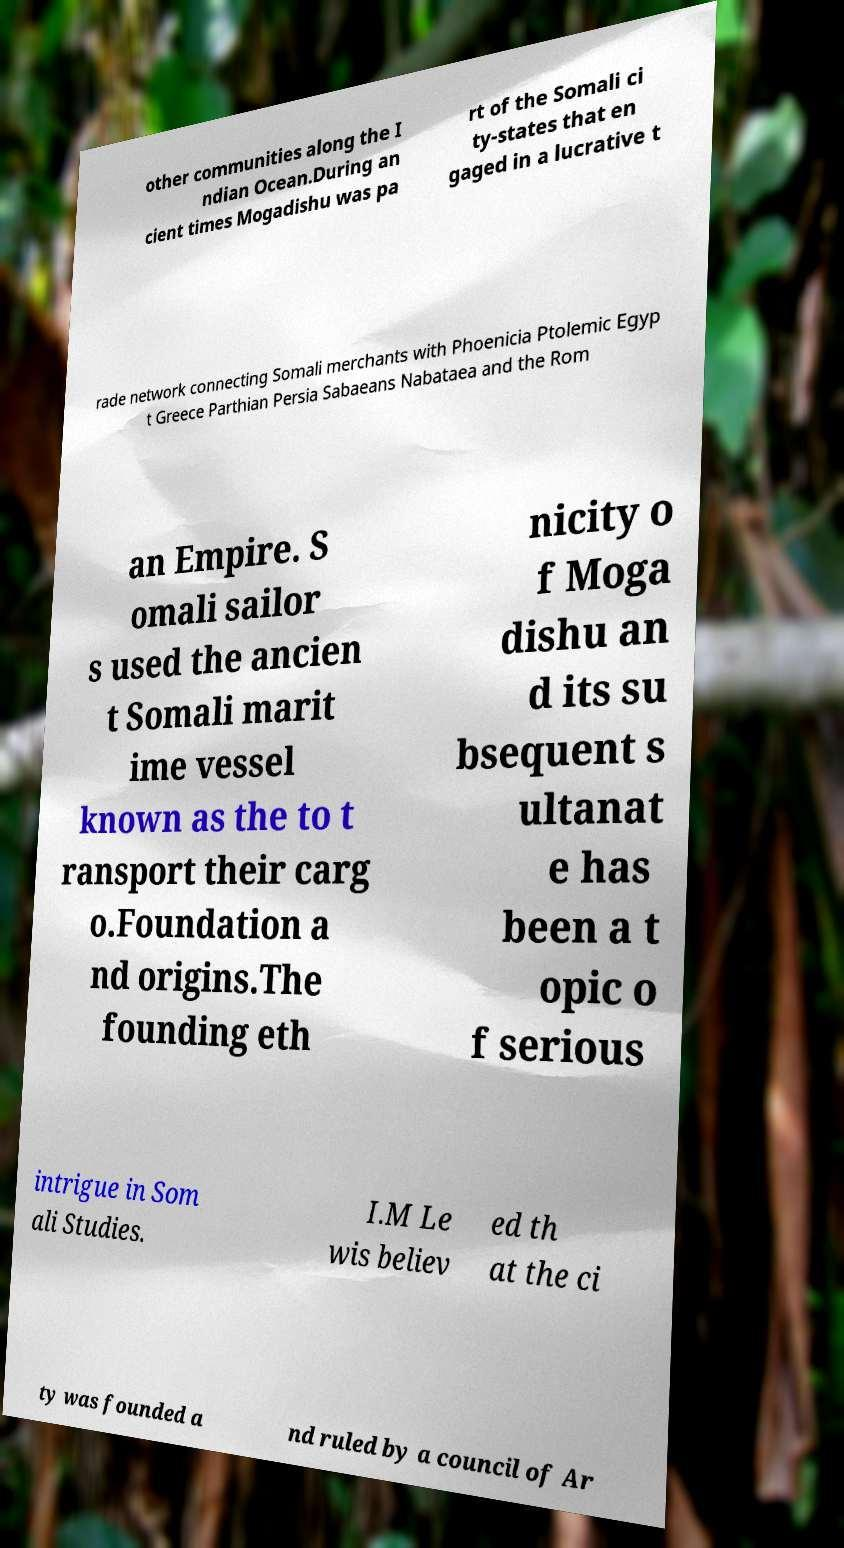Can you accurately transcribe the text from the provided image for me? other communities along the I ndian Ocean.During an cient times Mogadishu was pa rt of the Somali ci ty-states that en gaged in a lucrative t rade network connecting Somali merchants with Phoenicia Ptolemic Egyp t Greece Parthian Persia Sabaeans Nabataea and the Rom an Empire. S omali sailor s used the ancien t Somali marit ime vessel known as the to t ransport their carg o.Foundation a nd origins.The founding eth nicity o f Moga dishu an d its su bsequent s ultanat e has been a t opic o f serious intrigue in Som ali Studies. I.M Le wis believ ed th at the ci ty was founded a nd ruled by a council of Ar 